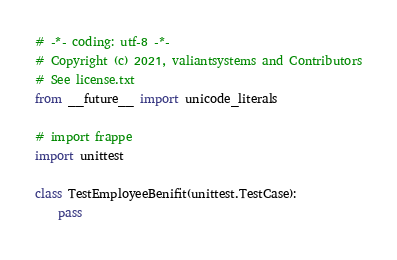Convert code to text. <code><loc_0><loc_0><loc_500><loc_500><_Python_># -*- coding: utf-8 -*-
# Copyright (c) 2021, valiantsystems and Contributors
# See license.txt
from __future__ import unicode_literals

# import frappe
import unittest

class TestEmployeeBenifit(unittest.TestCase):
	pass
</code> 